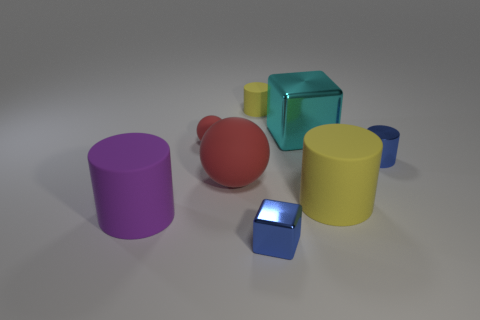How many yellow cylinders must be subtracted to get 1 yellow cylinders? 1 Add 1 red rubber spheres. How many objects exist? 9 Subtract all large yellow matte cylinders. How many cylinders are left? 3 Subtract all cubes. How many objects are left? 6 Subtract 1 cubes. How many cubes are left? 1 Subtract all purple cylinders. How many cylinders are left? 3 Subtract 0 brown blocks. How many objects are left? 8 Subtract all cyan balls. Subtract all red blocks. How many balls are left? 2 Subtract all yellow balls. How many blue cubes are left? 1 Subtract all metallic blocks. Subtract all yellow things. How many objects are left? 4 